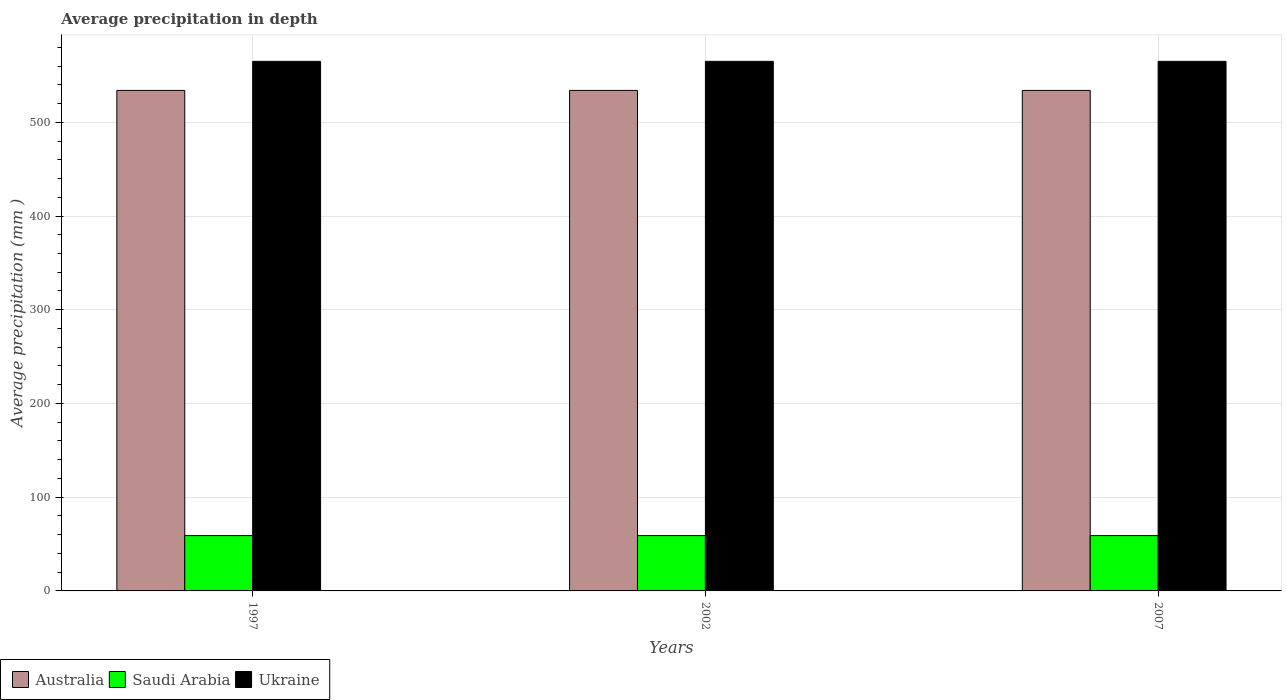How many different coloured bars are there?
Your answer should be very brief. 3. How many groups of bars are there?
Make the answer very short. 3. How many bars are there on the 3rd tick from the right?
Your answer should be very brief. 3. What is the average precipitation in Saudi Arabia in 2002?
Ensure brevity in your answer.  59. Across all years, what is the maximum average precipitation in Saudi Arabia?
Keep it short and to the point. 59. Across all years, what is the minimum average precipitation in Australia?
Provide a succinct answer. 534. In which year was the average precipitation in Saudi Arabia maximum?
Make the answer very short. 1997. What is the total average precipitation in Saudi Arabia in the graph?
Offer a terse response. 177. What is the difference between the average precipitation in Saudi Arabia in 2007 and the average precipitation in Australia in 2002?
Give a very brief answer. -475. What is the average average precipitation in Australia per year?
Ensure brevity in your answer.  534. In the year 2007, what is the difference between the average precipitation in Saudi Arabia and average precipitation in Australia?
Your answer should be very brief. -475. In how many years, is the average precipitation in Australia greater than 440 mm?
Make the answer very short. 3. What is the ratio of the average precipitation in Ukraine in 2002 to that in 2007?
Provide a short and direct response. 1. Is the average precipitation in Ukraine in 2002 less than that in 2007?
Offer a very short reply. No. Is the difference between the average precipitation in Saudi Arabia in 1997 and 2002 greater than the difference between the average precipitation in Australia in 1997 and 2002?
Your answer should be very brief. No. What is the difference between the highest and the second highest average precipitation in Australia?
Your answer should be compact. 0. In how many years, is the average precipitation in Saudi Arabia greater than the average average precipitation in Saudi Arabia taken over all years?
Keep it short and to the point. 0. Is the sum of the average precipitation in Australia in 1997 and 2002 greater than the maximum average precipitation in Saudi Arabia across all years?
Offer a very short reply. Yes. What does the 1st bar from the right in 1997 represents?
Offer a terse response. Ukraine. Is it the case that in every year, the sum of the average precipitation in Ukraine and average precipitation in Saudi Arabia is greater than the average precipitation in Australia?
Your answer should be very brief. Yes. Are the values on the major ticks of Y-axis written in scientific E-notation?
Provide a succinct answer. No. How many legend labels are there?
Give a very brief answer. 3. What is the title of the graph?
Make the answer very short. Average precipitation in depth. Does "West Bank and Gaza" appear as one of the legend labels in the graph?
Offer a terse response. No. What is the label or title of the X-axis?
Provide a succinct answer. Years. What is the label or title of the Y-axis?
Provide a succinct answer. Average precipitation (mm ). What is the Average precipitation (mm ) in Australia in 1997?
Keep it short and to the point. 534. What is the Average precipitation (mm ) in Saudi Arabia in 1997?
Your answer should be very brief. 59. What is the Average precipitation (mm ) in Ukraine in 1997?
Give a very brief answer. 565. What is the Average precipitation (mm ) in Australia in 2002?
Keep it short and to the point. 534. What is the Average precipitation (mm ) in Ukraine in 2002?
Your response must be concise. 565. What is the Average precipitation (mm ) in Australia in 2007?
Offer a terse response. 534. What is the Average precipitation (mm ) in Ukraine in 2007?
Give a very brief answer. 565. Across all years, what is the maximum Average precipitation (mm ) of Australia?
Your response must be concise. 534. Across all years, what is the maximum Average precipitation (mm ) in Saudi Arabia?
Ensure brevity in your answer.  59. Across all years, what is the maximum Average precipitation (mm ) of Ukraine?
Keep it short and to the point. 565. Across all years, what is the minimum Average precipitation (mm ) of Australia?
Offer a very short reply. 534. Across all years, what is the minimum Average precipitation (mm ) in Saudi Arabia?
Provide a short and direct response. 59. Across all years, what is the minimum Average precipitation (mm ) in Ukraine?
Offer a terse response. 565. What is the total Average precipitation (mm ) in Australia in the graph?
Provide a short and direct response. 1602. What is the total Average precipitation (mm ) of Saudi Arabia in the graph?
Keep it short and to the point. 177. What is the total Average precipitation (mm ) of Ukraine in the graph?
Make the answer very short. 1695. What is the difference between the Average precipitation (mm ) in Australia in 1997 and that in 2002?
Ensure brevity in your answer.  0. What is the difference between the Average precipitation (mm ) of Saudi Arabia in 1997 and that in 2002?
Make the answer very short. 0. What is the difference between the Average precipitation (mm ) of Australia in 1997 and that in 2007?
Offer a very short reply. 0. What is the difference between the Average precipitation (mm ) in Saudi Arabia in 2002 and that in 2007?
Your response must be concise. 0. What is the difference between the Average precipitation (mm ) of Australia in 1997 and the Average precipitation (mm ) of Saudi Arabia in 2002?
Make the answer very short. 475. What is the difference between the Average precipitation (mm ) of Australia in 1997 and the Average precipitation (mm ) of Ukraine in 2002?
Your answer should be compact. -31. What is the difference between the Average precipitation (mm ) of Saudi Arabia in 1997 and the Average precipitation (mm ) of Ukraine in 2002?
Give a very brief answer. -506. What is the difference between the Average precipitation (mm ) of Australia in 1997 and the Average precipitation (mm ) of Saudi Arabia in 2007?
Your answer should be very brief. 475. What is the difference between the Average precipitation (mm ) in Australia in 1997 and the Average precipitation (mm ) in Ukraine in 2007?
Your answer should be compact. -31. What is the difference between the Average precipitation (mm ) of Saudi Arabia in 1997 and the Average precipitation (mm ) of Ukraine in 2007?
Provide a short and direct response. -506. What is the difference between the Average precipitation (mm ) in Australia in 2002 and the Average precipitation (mm ) in Saudi Arabia in 2007?
Make the answer very short. 475. What is the difference between the Average precipitation (mm ) in Australia in 2002 and the Average precipitation (mm ) in Ukraine in 2007?
Offer a very short reply. -31. What is the difference between the Average precipitation (mm ) in Saudi Arabia in 2002 and the Average precipitation (mm ) in Ukraine in 2007?
Make the answer very short. -506. What is the average Average precipitation (mm ) in Australia per year?
Your response must be concise. 534. What is the average Average precipitation (mm ) of Saudi Arabia per year?
Your answer should be very brief. 59. What is the average Average precipitation (mm ) in Ukraine per year?
Offer a very short reply. 565. In the year 1997, what is the difference between the Average precipitation (mm ) in Australia and Average precipitation (mm ) in Saudi Arabia?
Your answer should be compact. 475. In the year 1997, what is the difference between the Average precipitation (mm ) in Australia and Average precipitation (mm ) in Ukraine?
Offer a terse response. -31. In the year 1997, what is the difference between the Average precipitation (mm ) in Saudi Arabia and Average precipitation (mm ) in Ukraine?
Offer a terse response. -506. In the year 2002, what is the difference between the Average precipitation (mm ) of Australia and Average precipitation (mm ) of Saudi Arabia?
Provide a succinct answer. 475. In the year 2002, what is the difference between the Average precipitation (mm ) in Australia and Average precipitation (mm ) in Ukraine?
Your answer should be compact. -31. In the year 2002, what is the difference between the Average precipitation (mm ) in Saudi Arabia and Average precipitation (mm ) in Ukraine?
Give a very brief answer. -506. In the year 2007, what is the difference between the Average precipitation (mm ) of Australia and Average precipitation (mm ) of Saudi Arabia?
Ensure brevity in your answer.  475. In the year 2007, what is the difference between the Average precipitation (mm ) in Australia and Average precipitation (mm ) in Ukraine?
Provide a succinct answer. -31. In the year 2007, what is the difference between the Average precipitation (mm ) in Saudi Arabia and Average precipitation (mm ) in Ukraine?
Provide a succinct answer. -506. What is the ratio of the Average precipitation (mm ) in Australia in 1997 to that in 2002?
Make the answer very short. 1. What is the ratio of the Average precipitation (mm ) in Ukraine in 1997 to that in 2002?
Your response must be concise. 1. What is the ratio of the Average precipitation (mm ) in Saudi Arabia in 1997 to that in 2007?
Provide a short and direct response. 1. What is the ratio of the Average precipitation (mm ) in Ukraine in 1997 to that in 2007?
Your response must be concise. 1. What is the ratio of the Average precipitation (mm ) in Australia in 2002 to that in 2007?
Your answer should be very brief. 1. What is the ratio of the Average precipitation (mm ) of Ukraine in 2002 to that in 2007?
Ensure brevity in your answer.  1. What is the difference between the highest and the second highest Average precipitation (mm ) in Australia?
Keep it short and to the point. 0. What is the difference between the highest and the lowest Average precipitation (mm ) of Australia?
Provide a succinct answer. 0. What is the difference between the highest and the lowest Average precipitation (mm ) in Ukraine?
Give a very brief answer. 0. 